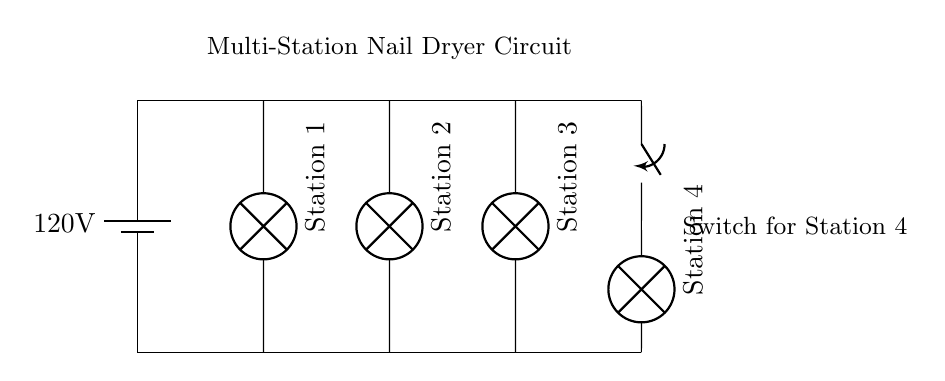What is the voltage of this circuit? The voltage in this circuit is identified from the battery, which is labeled as 120 volts.
Answer: 120 volts What does the switch control in the circuit? The switch in the circuit controls Station 4, allowing it to be turned on or off independently of the other stations. This is inferred from the connection of the switch directly to Station 4.
Answer: Station 4 How many nail dryer stations are there? The circuit diagram shows three lamp symbols representing Stations 1, 2, and 3, as well as one switch-controlled Station 4, totaling four stations.
Answer: Four stations Is the circuit connected in series or parallel? The configuration of the circuit, where each dryer station is connected directly to the same two voltage points, shows that it is connected in parallel. This means that each station operates independently of the others.
Answer: Parallel What is indicated by the labels near each station? The labels indicate the names and orientations of each station, helping to identify which lamp corresponds to which drying station. Each label shows the number of the station (1 through 4).
Answer: Station 1, Station 2, Station 3, Station 4 